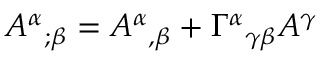<formula> <loc_0><loc_0><loc_500><loc_500>A ^ { \alpha _ { ; \beta } = A ^ { \alpha _ { , \beta } + \Gamma ^ { \alpha _ { \gamma \beta } A ^ { \gamma }</formula> 